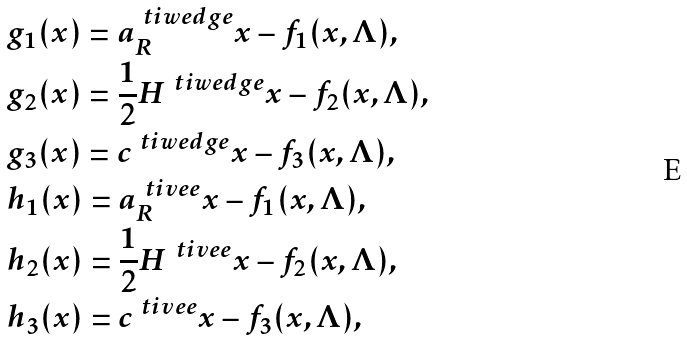<formula> <loc_0><loc_0><loc_500><loc_500>& g _ { 1 } ( x ) = a _ { R } ^ { \ t i w e d g e } x - f _ { 1 } ( x , \Lambda ) , \\ & g _ { 2 } ( x ) = \frac { 1 } { 2 } H ^ { \ t i w e d g e } x - f _ { 2 } ( x , \Lambda ) , \\ & g _ { 3 } ( x ) = c ^ { \ t i w e d g e } x - f _ { 3 } ( x , \Lambda ) , \\ & h _ { 1 } ( x ) = a _ { R } ^ { \ t i v e e } x - f _ { 1 } ( x , \Lambda ) , \\ & h _ { 2 } ( x ) = \frac { 1 } { 2 } H ^ { \ t i v e e } x - f _ { 2 } ( x , \Lambda ) , \\ & h _ { 3 } ( x ) = c ^ { \ t i v e e } x - f _ { 3 } ( x , \Lambda ) ,</formula> 